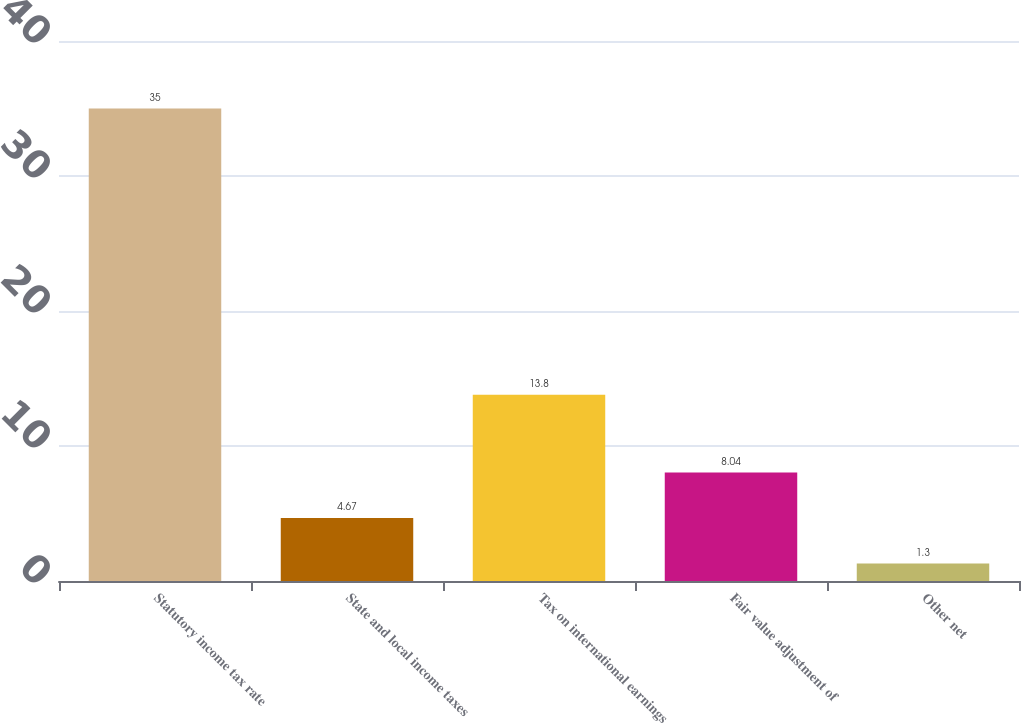Convert chart to OTSL. <chart><loc_0><loc_0><loc_500><loc_500><bar_chart><fcel>Statutory income tax rate<fcel>State and local income taxes<fcel>Tax on international earnings<fcel>Fair value adjustment of<fcel>Other net<nl><fcel>35<fcel>4.67<fcel>13.8<fcel>8.04<fcel>1.3<nl></chart> 